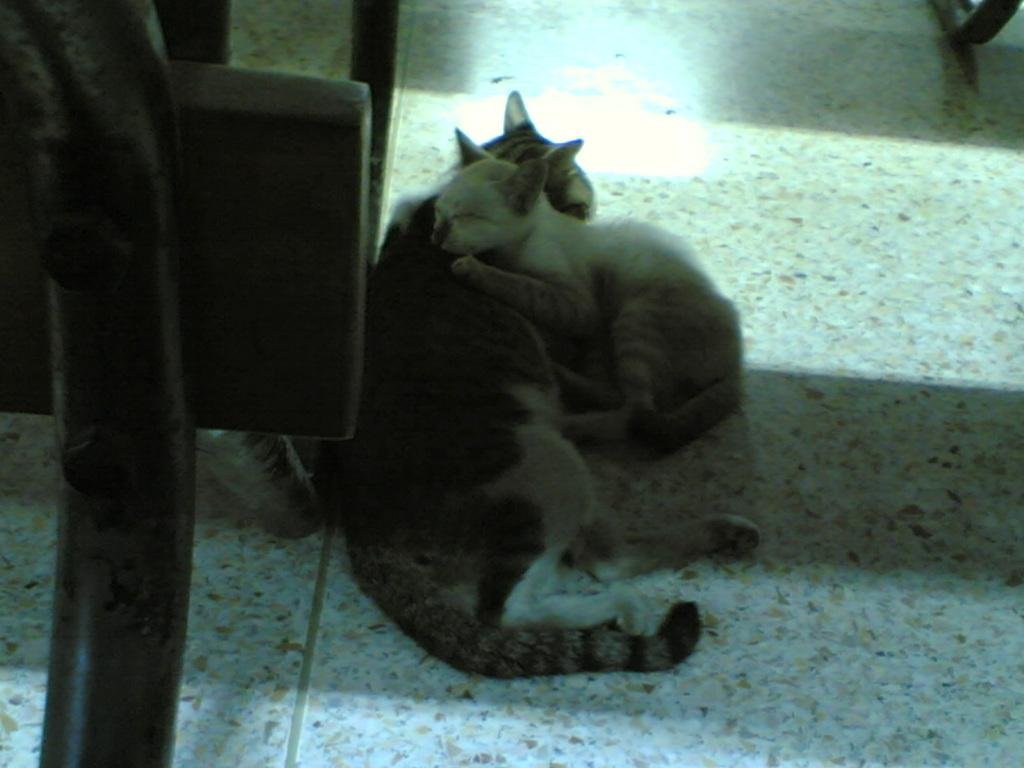What type of animals are in the image? There are cats in the image. What position are the cats in? The cats are lying on the floor. Can you describe the interaction between the cats? One cat is on top of another cat. What type of berry is being held by the governor in the image? There is no governor or berry present in the image; it features cats lying on the floor. 